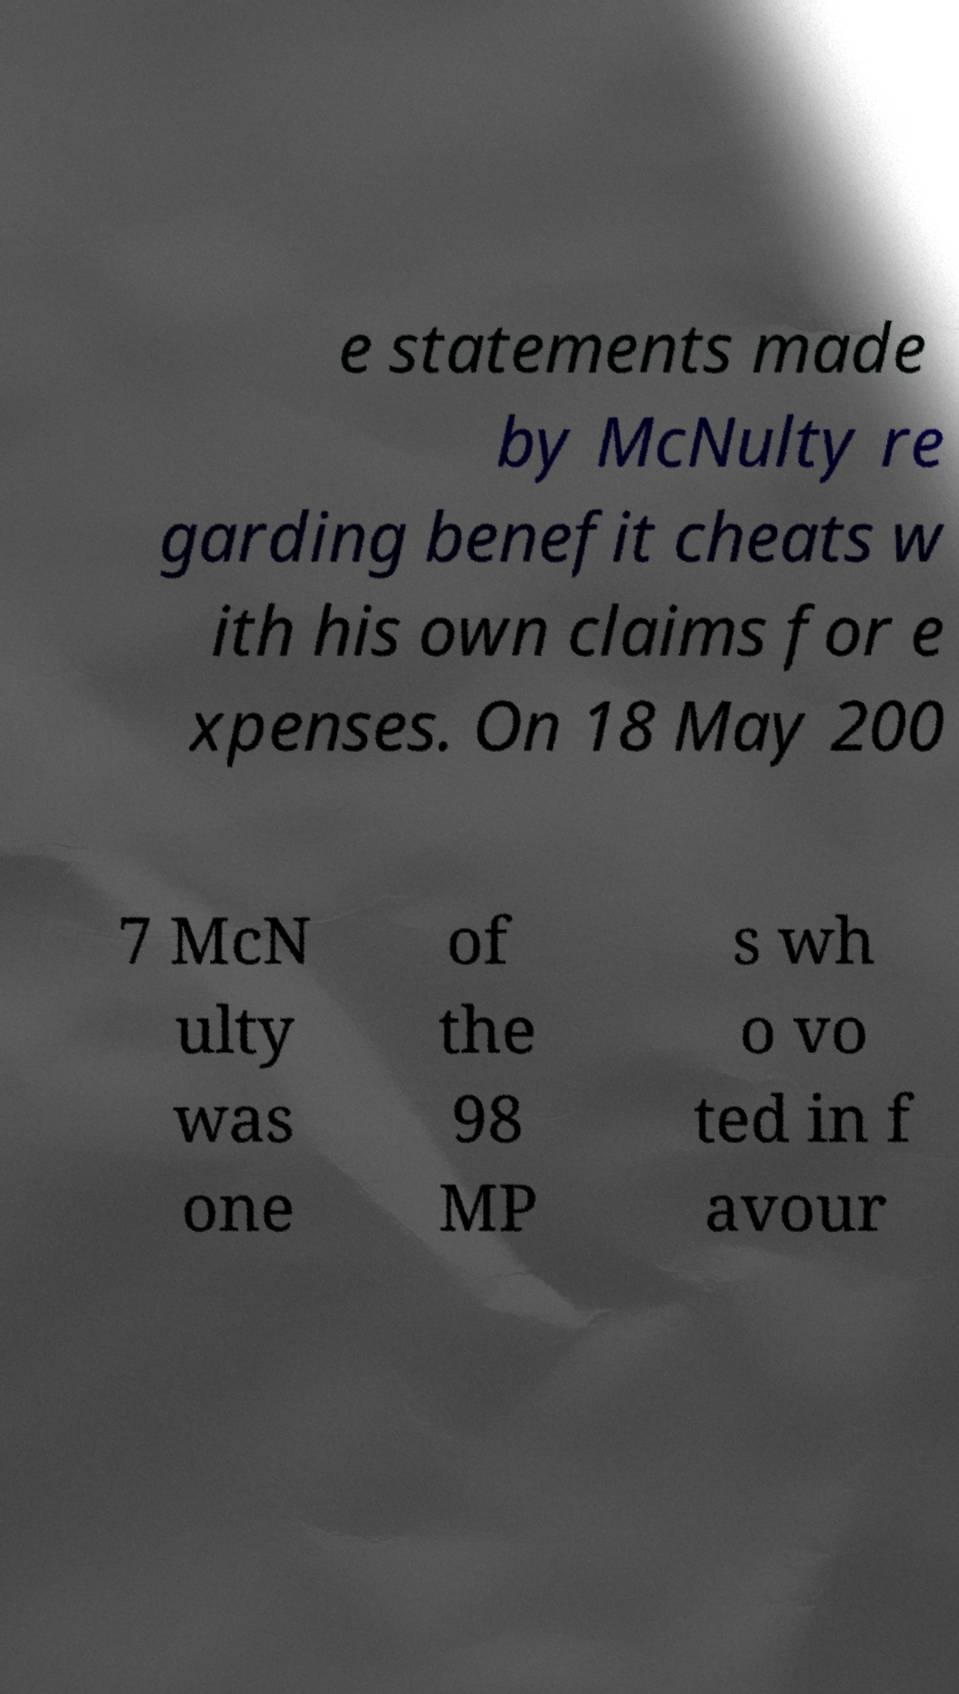Could you assist in decoding the text presented in this image and type it out clearly? e statements made by McNulty re garding benefit cheats w ith his own claims for e xpenses. On 18 May 200 7 McN ulty was one of the 98 MP s wh o vo ted in f avour 